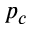Convert formula to latex. <formula><loc_0><loc_0><loc_500><loc_500>p _ { c }</formula> 